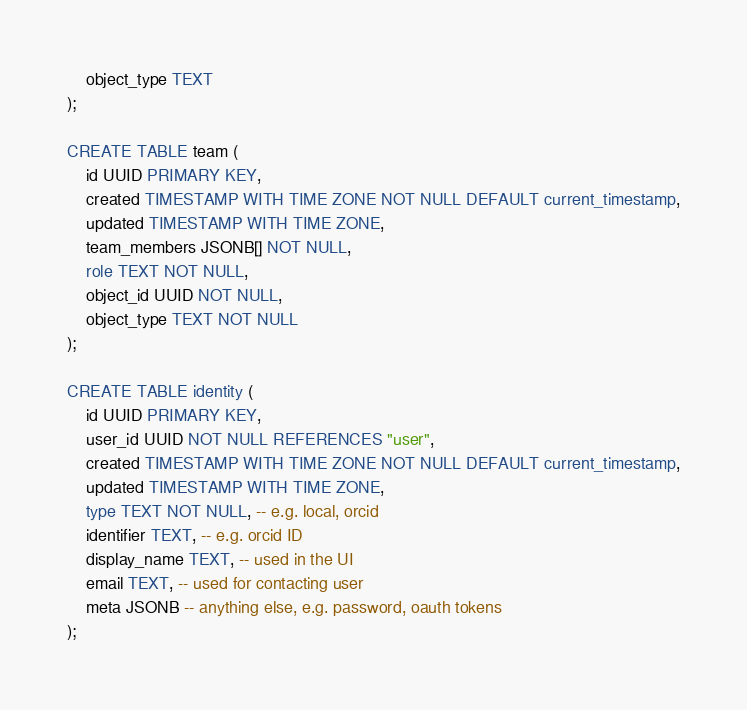<code> <loc_0><loc_0><loc_500><loc_500><_SQL_>    object_type TEXT
);

CREATE TABLE team (
    id UUID PRIMARY KEY,
    created TIMESTAMP WITH TIME ZONE NOT NULL DEFAULT current_timestamp,
    updated TIMESTAMP WITH TIME ZONE,
    team_members JSONB[] NOT NULL,
    role TEXT NOT NULL,
    object_id UUID NOT NULL,
    object_type TEXT NOT NULL
);

CREATE TABLE identity (
    id UUID PRIMARY KEY,
    user_id UUID NOT NULL REFERENCES "user",
    created TIMESTAMP WITH TIME ZONE NOT NULL DEFAULT current_timestamp,
    updated TIMESTAMP WITH TIME ZONE,
    type TEXT NOT NULL, -- e.g. local, orcid
    identifier TEXT, -- e.g. orcid ID
    display_name TEXT, -- used in the UI
    email TEXT, -- used for contacting user
    meta JSONB -- anything else, e.g. password, oauth tokens
);</code> 